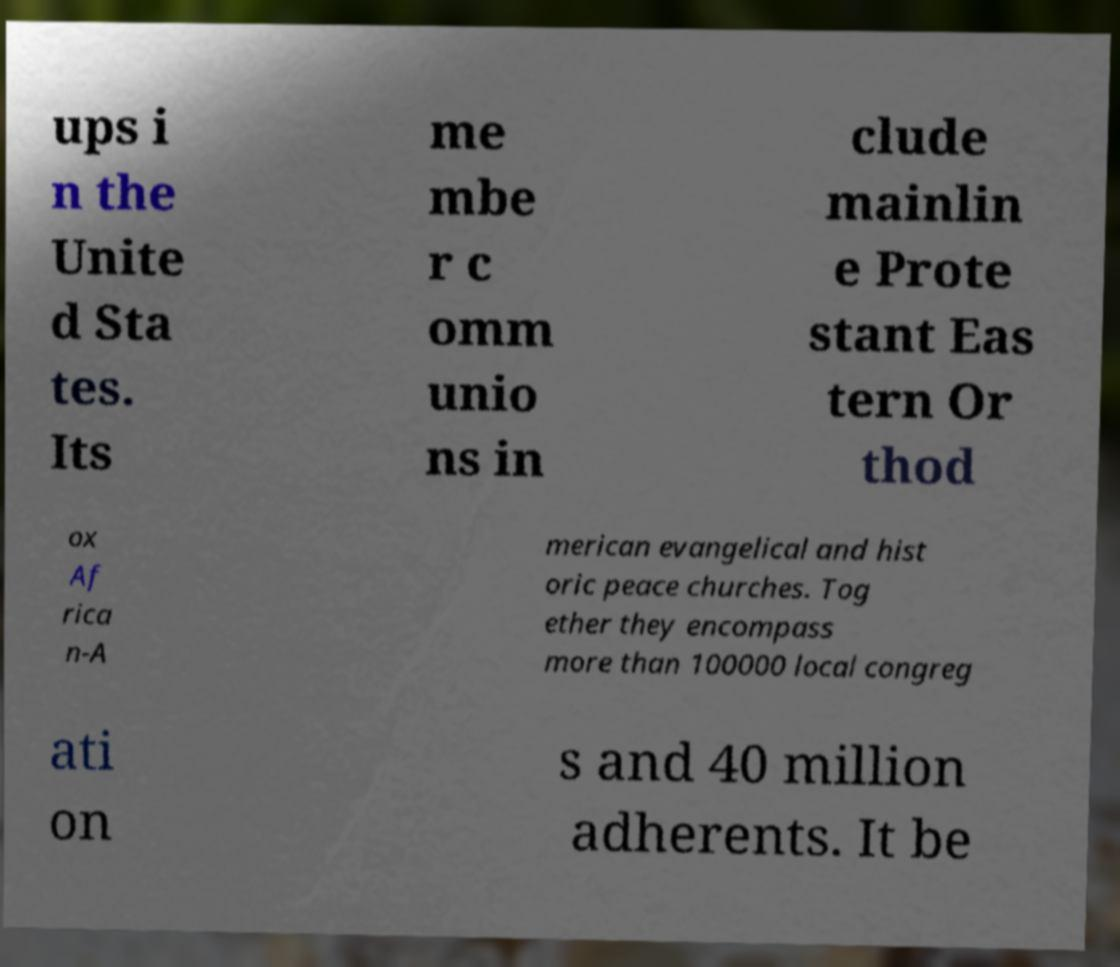Could you assist in decoding the text presented in this image and type it out clearly? ups i n the Unite d Sta tes. Its me mbe r c omm unio ns in clude mainlin e Prote stant Eas tern Or thod ox Af rica n-A merican evangelical and hist oric peace churches. Tog ether they encompass more than 100000 local congreg ati on s and 40 million adherents. It be 